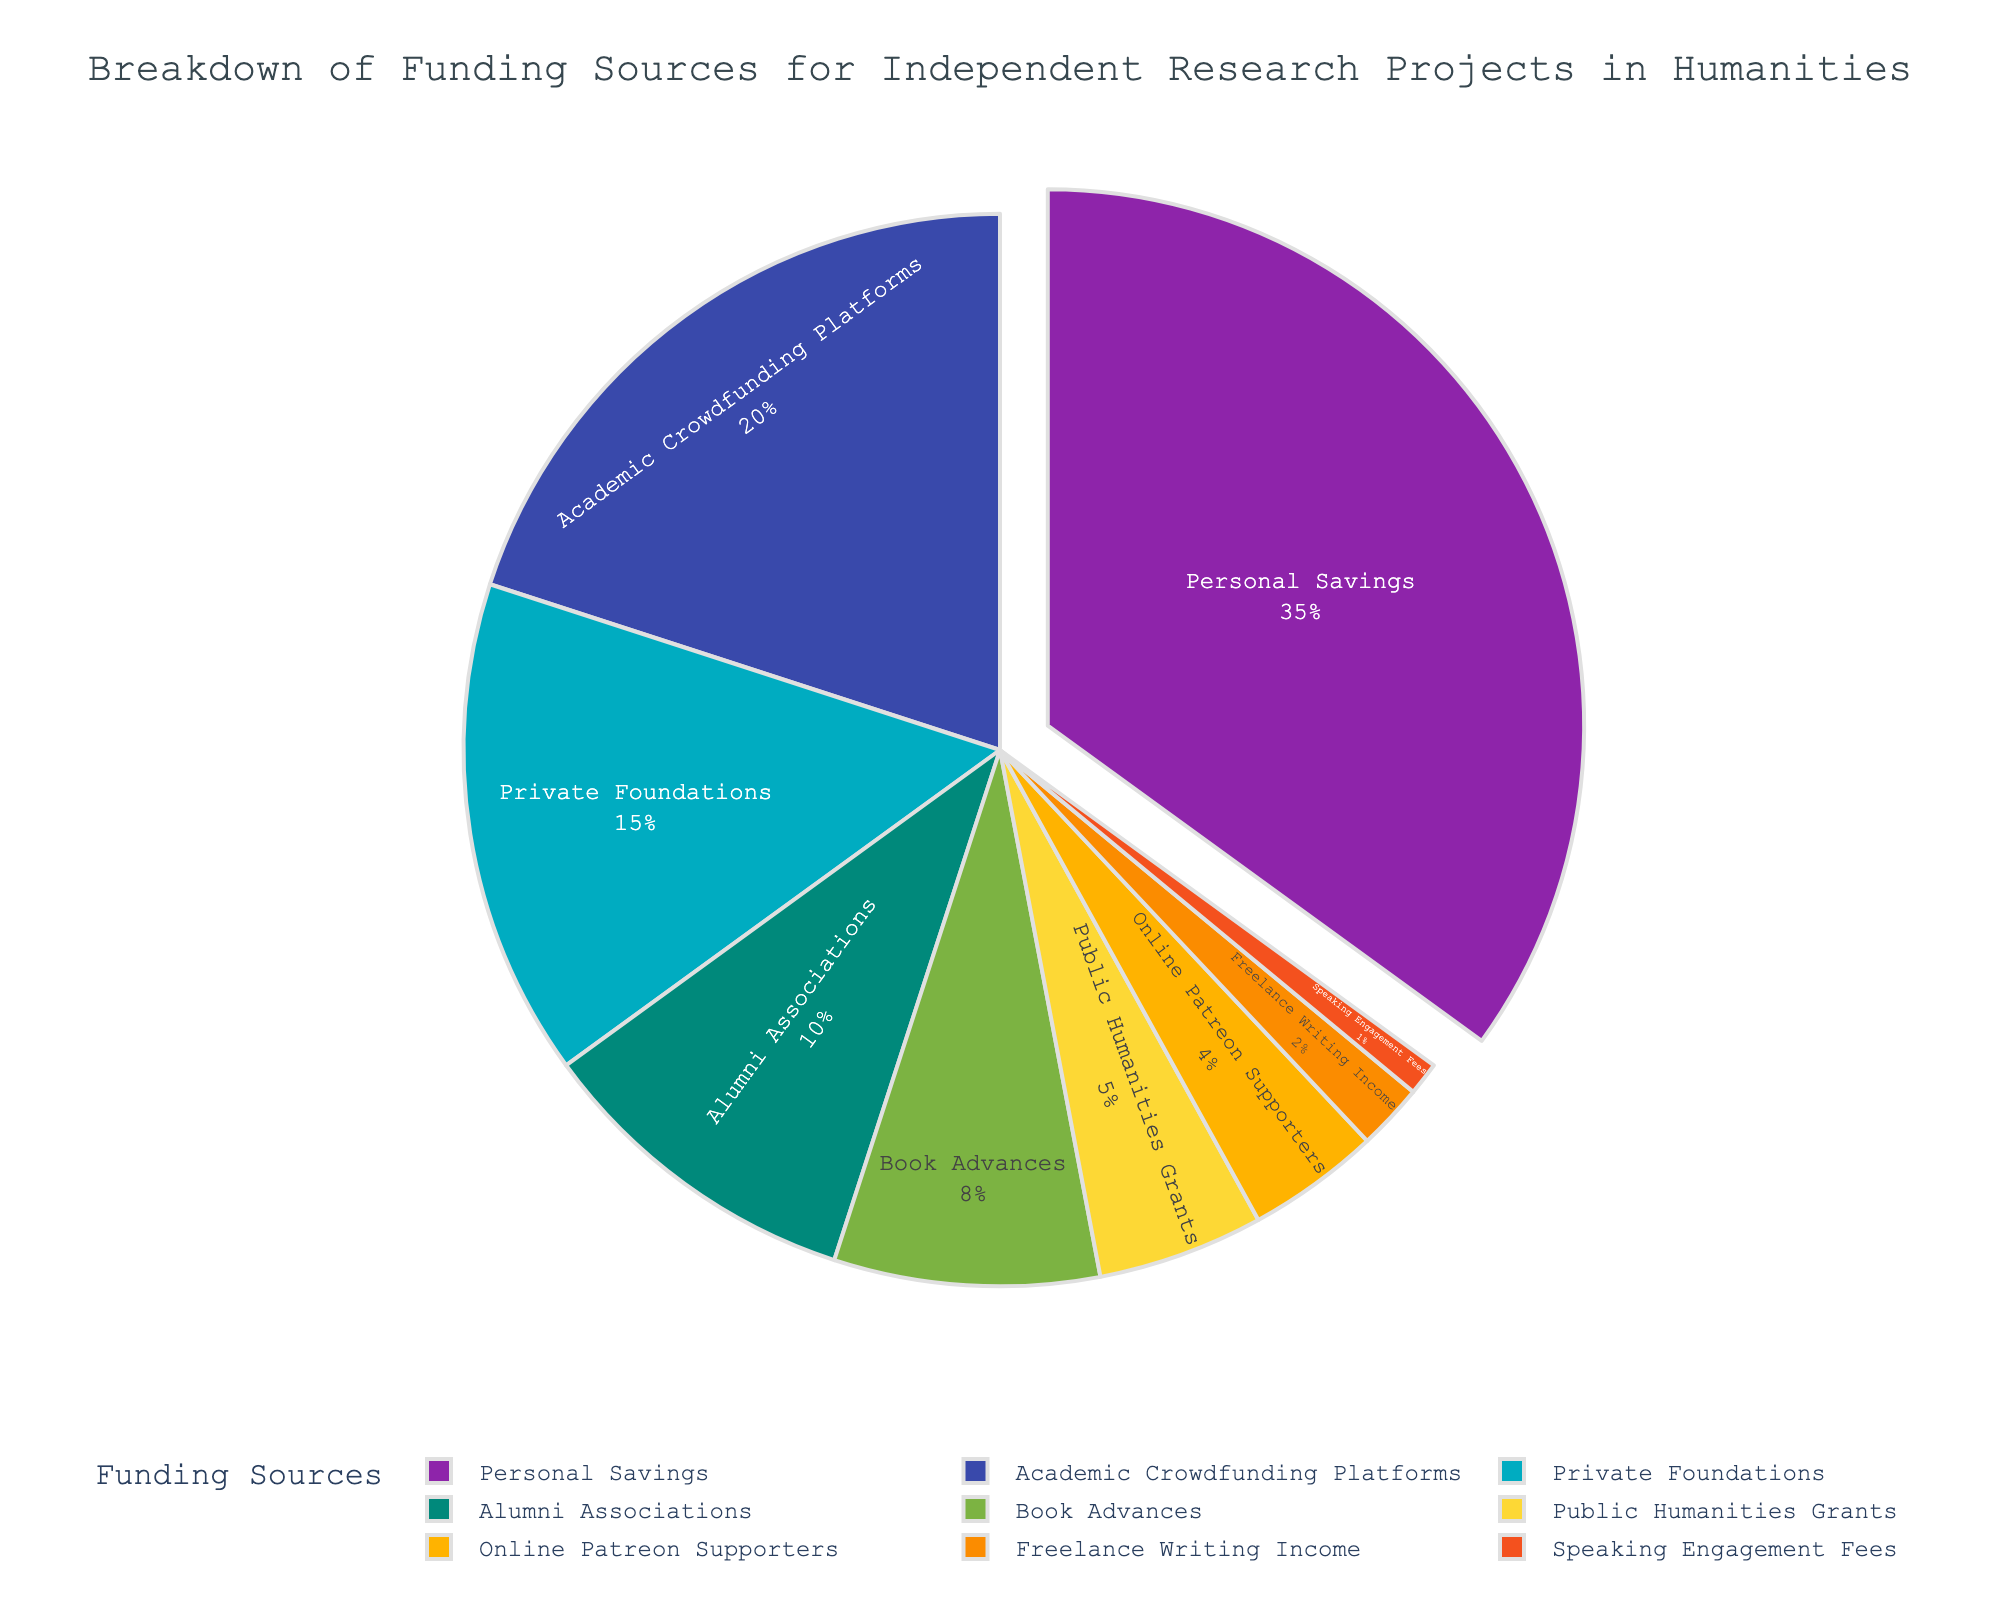What is the largest funding source for independent research projects in the humanities? The largest sector on the pie chart is highlighted and represents 35% of the total. This sector is labeled as "Personal Savings."
Answer: Personal Savings Which funding sources collectively contribute to more than 50% of the total funding? The funding sources "Personal Savings" (35%) and "Academic Crowdfunding Platforms" (20%) collectively contribute 55%, which is more than 50%.
Answer: Personal Savings and Academic Crowdfunding Platforms What is the combined percentage of Private Foundations and Alumni Associations? The percentage for Private Foundations is 15% and for Alumni Associations is 10%. Adding them together, 15% + 10% = 25%.
Answer: 25% How much more funding does Personal Savings provide compared to Public Humanities Grants? Personal Savings contributes 35%. Public Humanities Grants contribute 5%. To find the difference, subtract 5% from 35%: 35% - 5% = 30%.
Answer: 30% What fraction of the funding sources contribute less than 10% each? The sectors with less than 10% each are "Alumni Associations" (10%), "Book Advances" (8%), "Public Humanities Grants" (5%), "Online Patreon Supporters" (4%), "Freelance Writing Income" (2%), and "Speaking Engagement Fees" (1%). There are 9 total sources, so 6 out of 9 contribute less than 10%.
Answer: 6/9 Which funding source has the smallest contribution, and what is its percentage? The smallest sector visually is the one labeled "Speaking Engagement Fees," which represents 1% of the total funding.
Answer: Speaking Engagement Fees, 1% Is the combined contribution of Book Advances and Online Patreon Supporters greater than Alumni Associations? Book Advances contribute 8% and Online Patreon Supporters contribute 4%. Adding them, 8% + 4% = 12%, which is greater than Alumni Associations' 10%.
Answer: Yes What color represents Private Foundations in the pie chart? The sector for Private Foundations is depicted with the fourth color in the given custom color palette, which corresponds to a turquoise shade.
Answer: Turquoise How does the amount of funding from Book Advances compare to that from Public Humanities Grants? Book Advances provide 8% of the funding, whereas Public Humanities Grants provide 5%. Since 8% is greater than 5%, Book Advances contribute more funding.
Answer: More What is the percentage contribution of the three least contributing sources combined? The three least contributing sources are "Speaking Engagement Fees" (1%), "Freelance Writing Income" (2%), and "Online Patreon Supporters" (4%). Adding them together, 1% + 2% + 4% = 7%.
Answer: 7% 